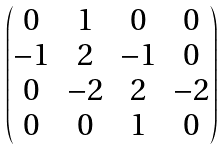Convert formula to latex. <formula><loc_0><loc_0><loc_500><loc_500>\begin{pmatrix} 0 & 1 & 0 & 0 \\ - 1 & 2 & - 1 & 0 \\ 0 & - 2 & 2 & - 2 \\ 0 & 0 & 1 & 0 \end{pmatrix}</formula> 